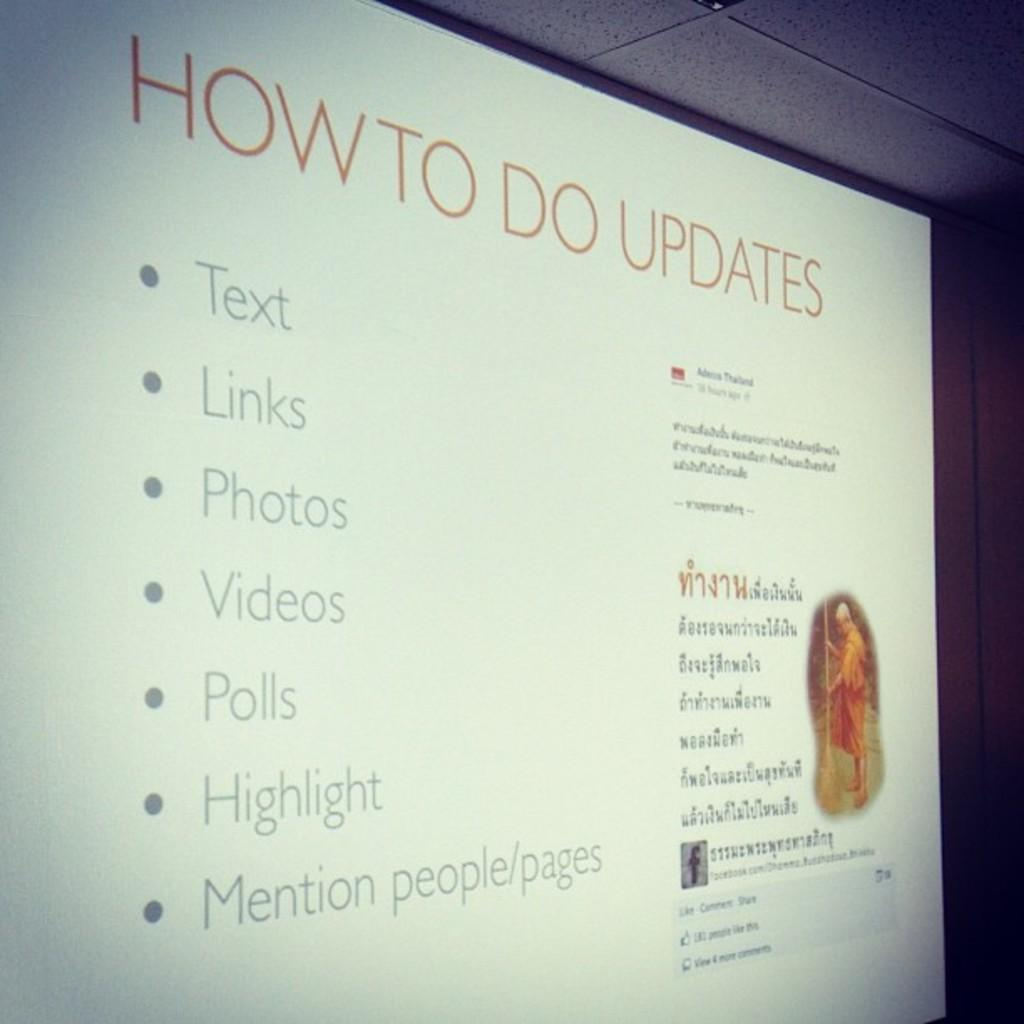<image>
Write a terse but informative summary of the picture. A screen says "how to do updates" and has a bullet-point list on it. 